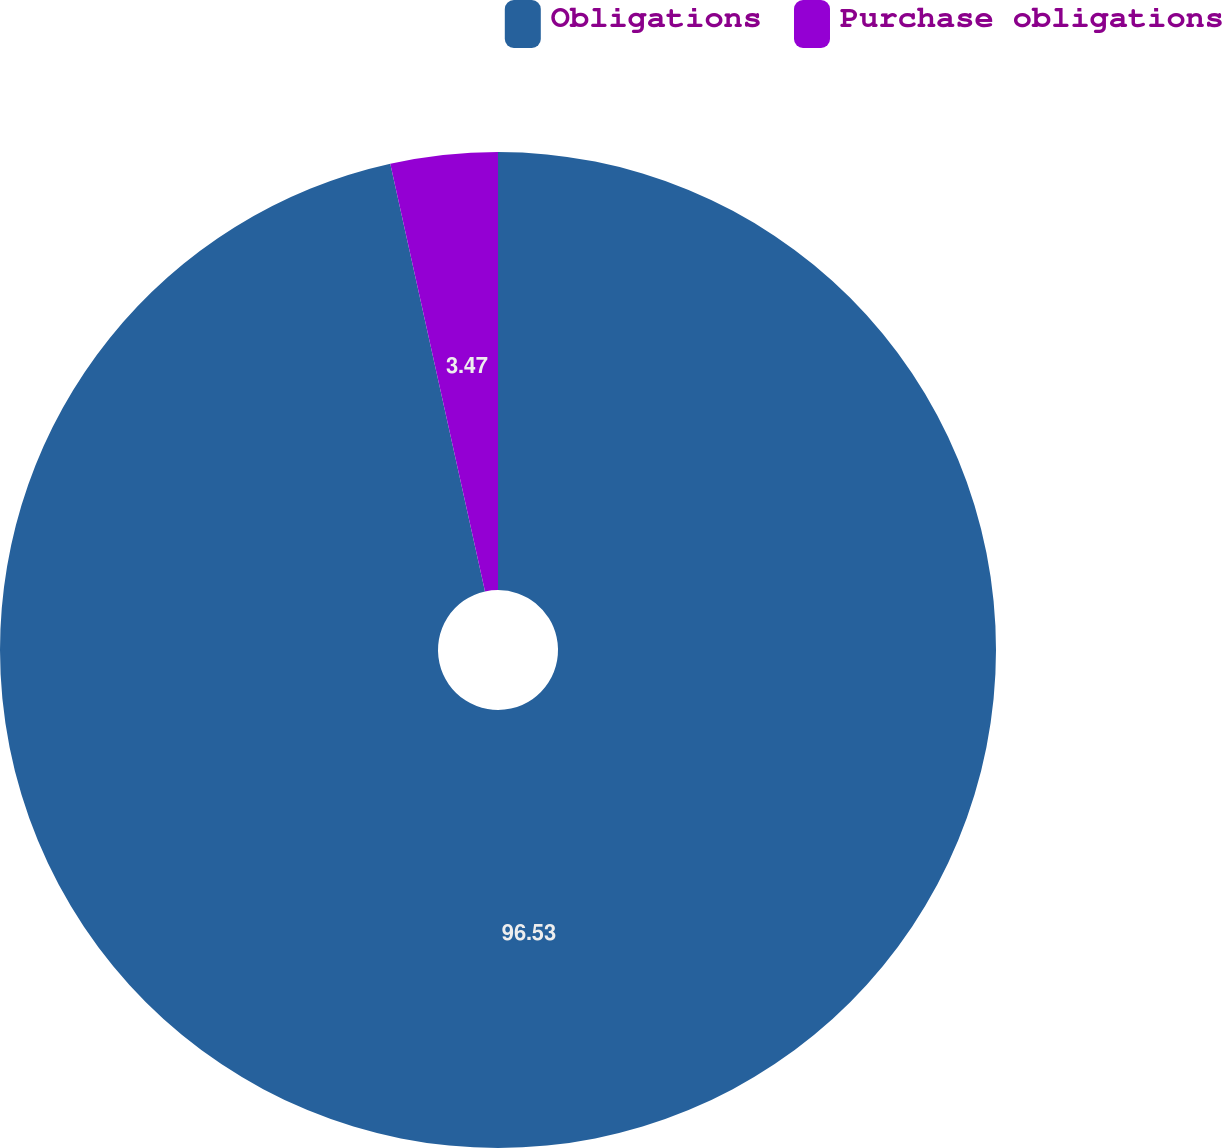Convert chart. <chart><loc_0><loc_0><loc_500><loc_500><pie_chart><fcel>Obligations<fcel>Purchase obligations<nl><fcel>96.53%<fcel>3.47%<nl></chart> 